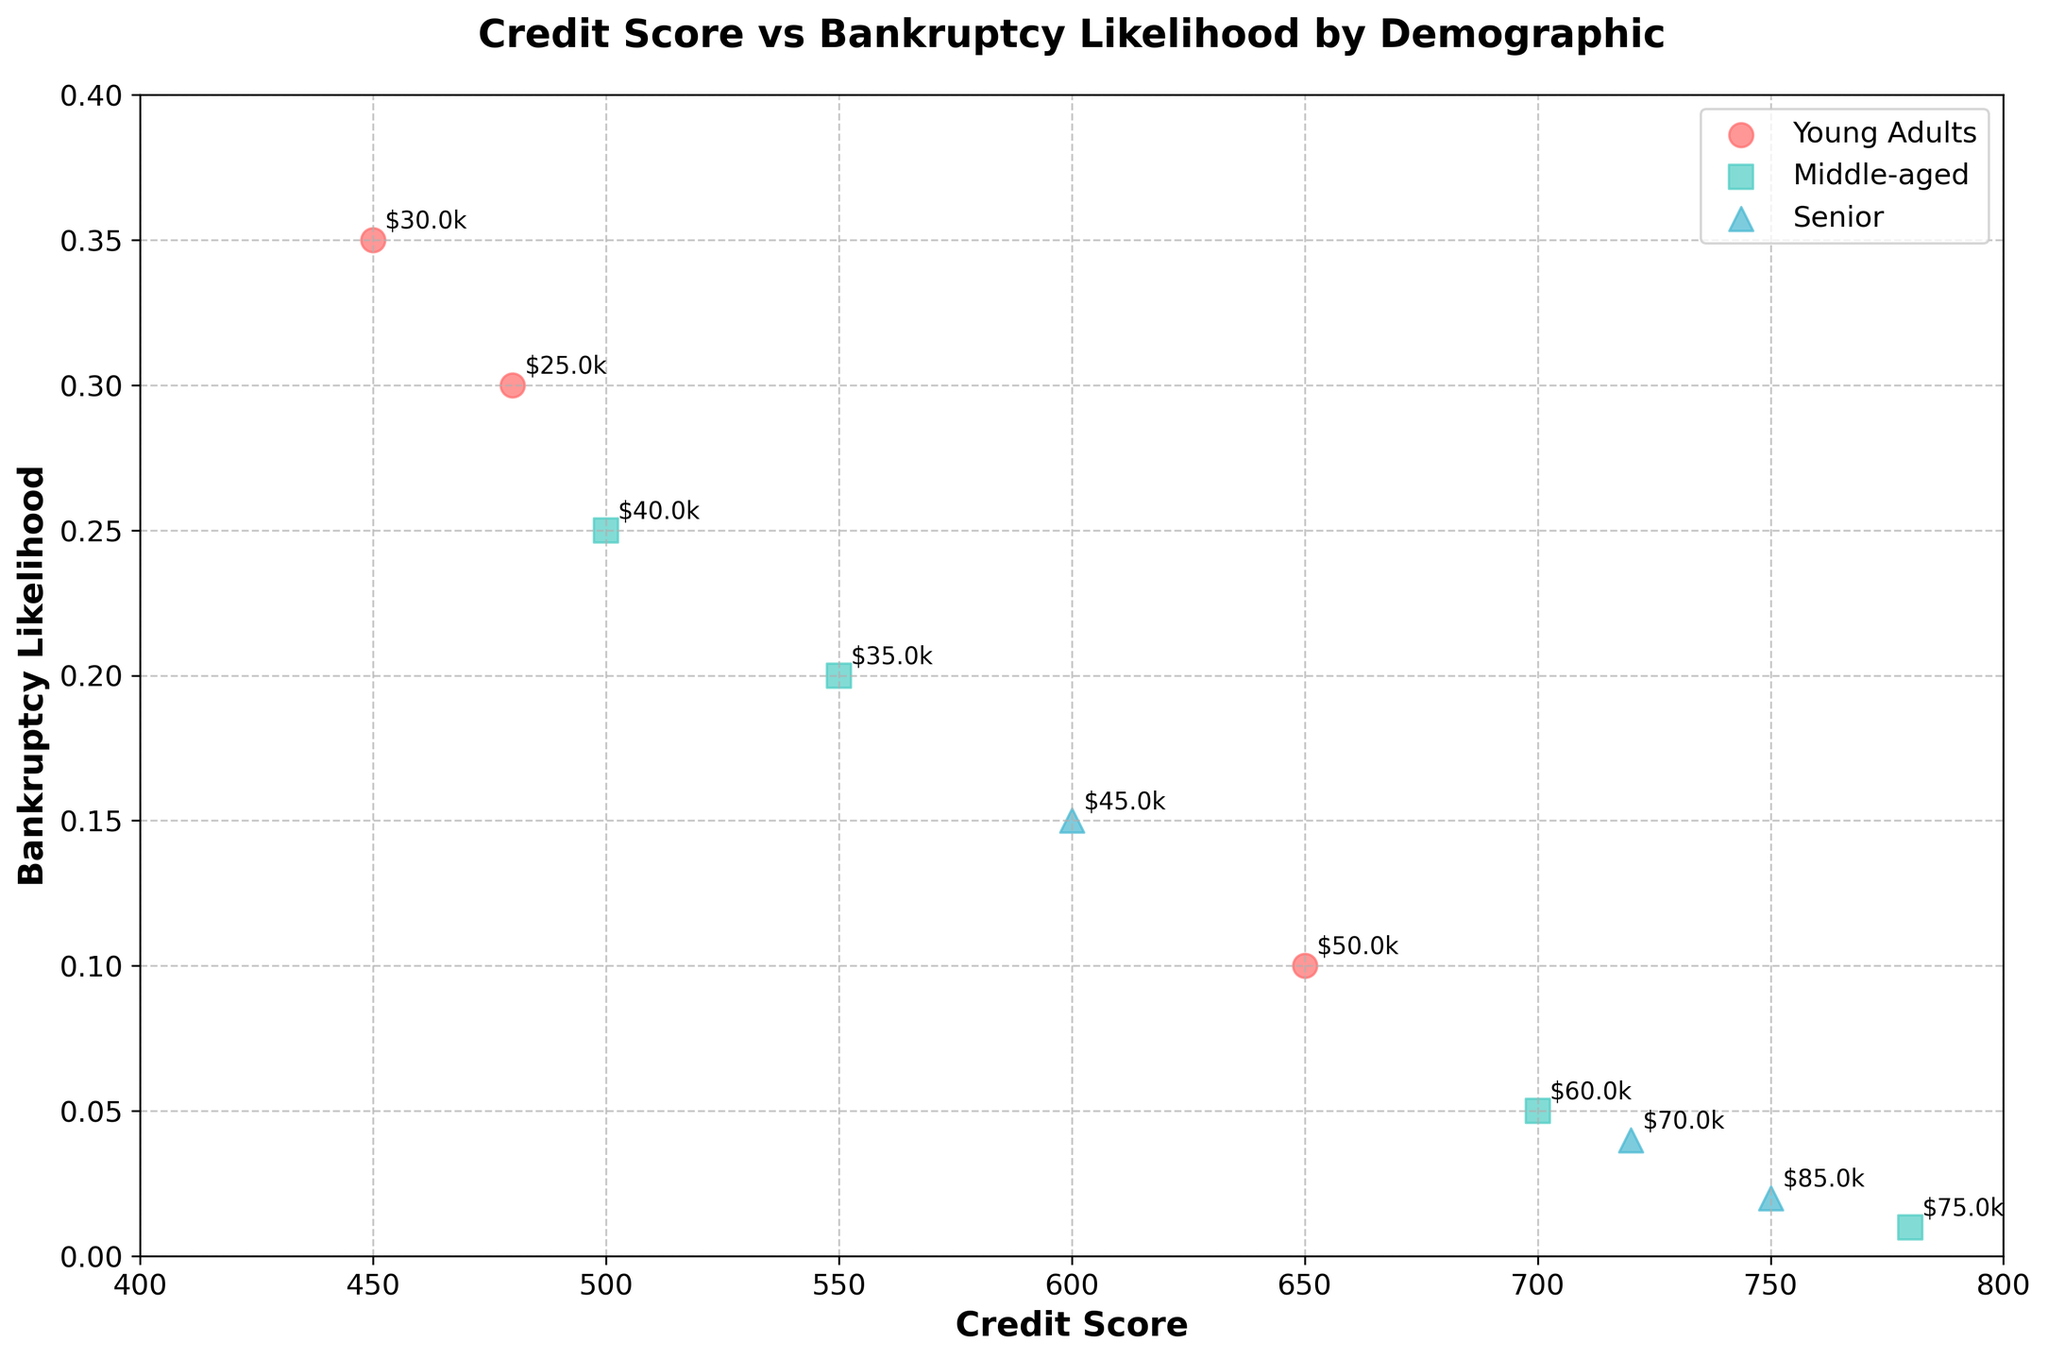What is the title of the plot? The title is displayed at the top of the figure, indicating the main topic of the visualization.
Answer: Credit Score vs Bankruptcy Likelihood by Demographic What is the credit score range shown in the plot? The x-axis represents Credit Score, and the range can be inferred from the axis limits.
Answer: 400-800 Which demographic has the highest bankruptcy likelihood? By looking at which color and marker have the highest points on the y-axis (Bankruptcy Likelihood), we can identify the demographic.
Answer: Young Adults How does bankruptcy likelihood generally change as credit score increases? Observing the trend of points on the plot, we see that as the credit scores increase (move right on the x-axis), the bankruptcy likelihood (y-axis) tends to decrease.
Answer: Decreases What is the bankruptcy likelihood for Senior individuals with a credit score of 720? Locate the Senior demographic's color and marker, then find the specific point at a credit score of 720 on the x-axis and see the corresponding y-axis value.
Answer: 0.04 Which group has a lower bankruptcy likelihood, Middle-aged individuals with a credit score of 700 or Young Adults with a credit score of 650? Compare the y-axis values at the credit scores of 700 (Middle-aged) and 650 (Young Adults) to determine which is lower.
Answer: Middle-aged at 700 How many distinct demographics are represented in the plot? Look at the legend to count the number of unique demographics displayed.
Answer: 3 What is the bankruptcy likelihood for Middle-aged individuals with a credit score of 500? Identify the Middle-aged group's color and marker, then find the value on the y-axis for a credit score of 500.
Answer: 0.25 Identify the marker and color combination representing Senior individuals. The legend associates each demographic with a specific marker shape and color.
Answer: Triangle and teal Which demographic has the lowest general income among those plotted? Check the annotations near each data point that indicate income levels to identify the demographic with generally lower income levels.
Answer: Young Adults 